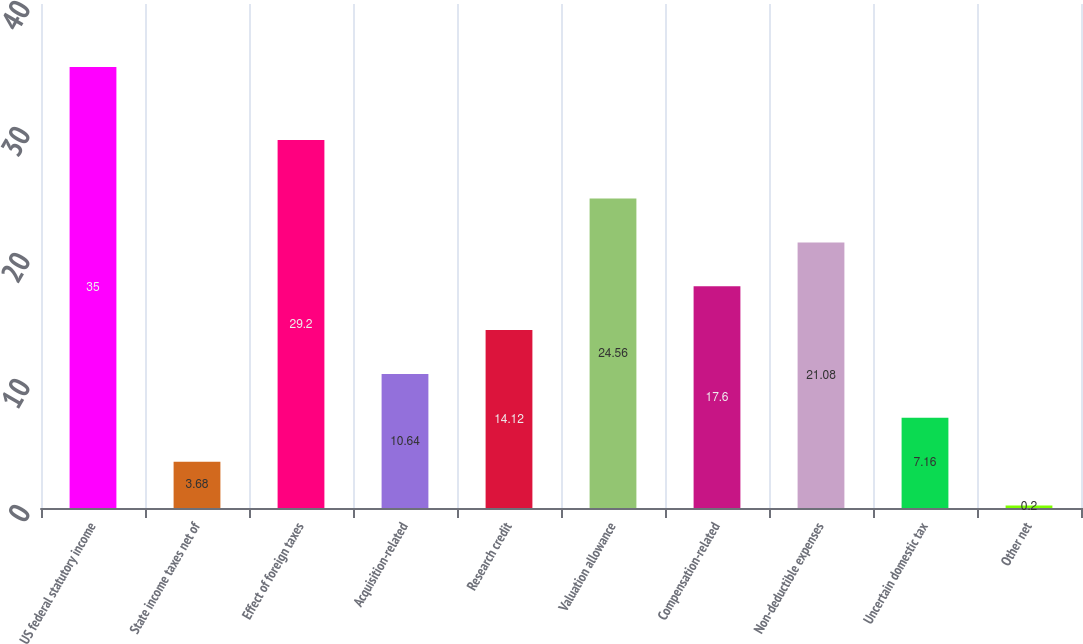Convert chart. <chart><loc_0><loc_0><loc_500><loc_500><bar_chart><fcel>US federal statutory income<fcel>State income taxes net of<fcel>Effect of foreign taxes<fcel>Acquisition-related<fcel>Research credit<fcel>Valuation allowance<fcel>Compensation-related<fcel>Non-deductible expenses<fcel>Uncertain domestic tax<fcel>Other net<nl><fcel>35<fcel>3.68<fcel>29.2<fcel>10.64<fcel>14.12<fcel>24.56<fcel>17.6<fcel>21.08<fcel>7.16<fcel>0.2<nl></chart> 